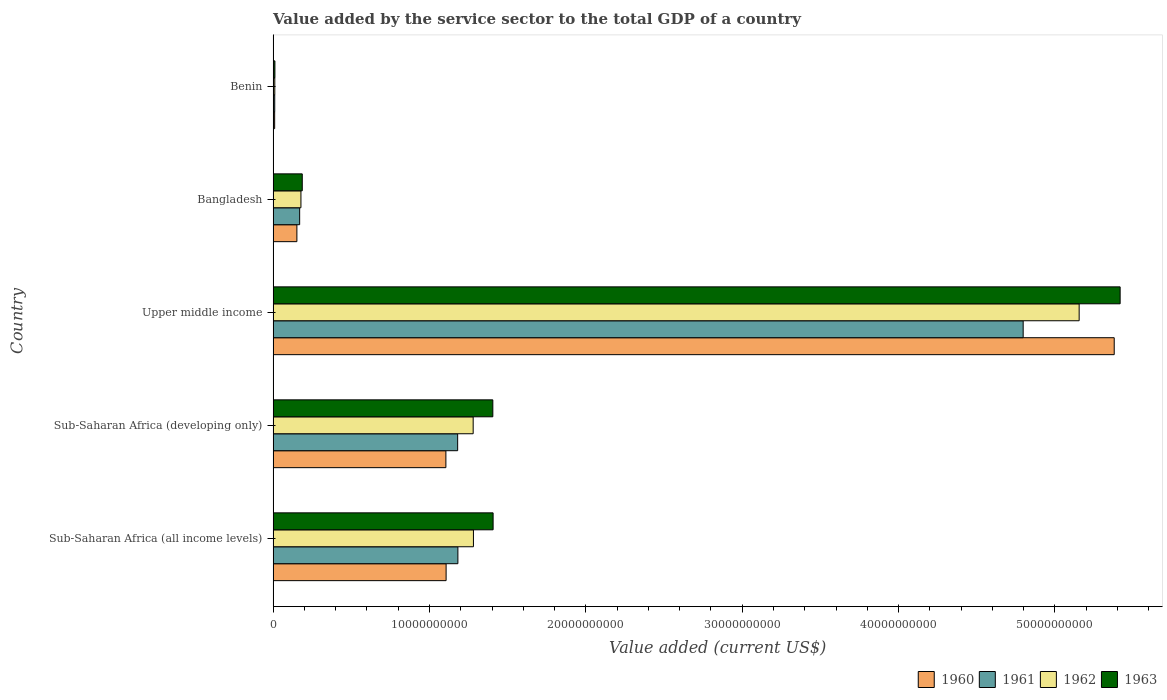How many different coloured bars are there?
Give a very brief answer. 4. How many groups of bars are there?
Your answer should be compact. 5. Are the number of bars on each tick of the Y-axis equal?
Ensure brevity in your answer.  Yes. How many bars are there on the 3rd tick from the top?
Keep it short and to the point. 4. How many bars are there on the 3rd tick from the bottom?
Make the answer very short. 4. What is the label of the 3rd group of bars from the top?
Keep it short and to the point. Upper middle income. In how many cases, is the number of bars for a given country not equal to the number of legend labels?
Your answer should be very brief. 0. What is the value added by the service sector to the total GDP in 1963 in Upper middle income?
Ensure brevity in your answer.  5.42e+1. Across all countries, what is the maximum value added by the service sector to the total GDP in 1962?
Ensure brevity in your answer.  5.16e+1. Across all countries, what is the minimum value added by the service sector to the total GDP in 1963?
Offer a very short reply. 1.14e+08. In which country was the value added by the service sector to the total GDP in 1960 maximum?
Make the answer very short. Upper middle income. In which country was the value added by the service sector to the total GDP in 1960 minimum?
Make the answer very short. Benin. What is the total value added by the service sector to the total GDP in 1962 in the graph?
Provide a short and direct response. 7.90e+1. What is the difference between the value added by the service sector to the total GDP in 1960 in Bangladesh and that in Sub-Saharan Africa (developing only)?
Your answer should be compact. -9.53e+09. What is the difference between the value added by the service sector to the total GDP in 1961 in Benin and the value added by the service sector to the total GDP in 1960 in Upper middle income?
Your answer should be compact. -5.37e+1. What is the average value added by the service sector to the total GDP in 1962 per country?
Keep it short and to the point. 1.58e+1. What is the difference between the value added by the service sector to the total GDP in 1960 and value added by the service sector to the total GDP in 1961 in Sub-Saharan Africa (developing only)?
Keep it short and to the point. -7.52e+08. What is the ratio of the value added by the service sector to the total GDP in 1963 in Benin to that in Sub-Saharan Africa (developing only)?
Give a very brief answer. 0.01. What is the difference between the highest and the second highest value added by the service sector to the total GDP in 1960?
Offer a very short reply. 4.27e+1. What is the difference between the highest and the lowest value added by the service sector to the total GDP in 1961?
Offer a terse response. 4.79e+1. Is the sum of the value added by the service sector to the total GDP in 1963 in Bangladesh and Upper middle income greater than the maximum value added by the service sector to the total GDP in 1960 across all countries?
Your answer should be very brief. Yes. What does the 2nd bar from the top in Sub-Saharan Africa (developing only) represents?
Your answer should be very brief. 1962. What does the 1st bar from the bottom in Benin represents?
Provide a succinct answer. 1960. Are all the bars in the graph horizontal?
Provide a short and direct response. Yes. What is the difference between two consecutive major ticks on the X-axis?
Your answer should be very brief. 1.00e+1. Are the values on the major ticks of X-axis written in scientific E-notation?
Your answer should be compact. No. Does the graph contain any zero values?
Your answer should be very brief. No. Does the graph contain grids?
Make the answer very short. No. What is the title of the graph?
Your answer should be compact. Value added by the service sector to the total GDP of a country. Does "1967" appear as one of the legend labels in the graph?
Keep it short and to the point. No. What is the label or title of the X-axis?
Give a very brief answer. Value added (current US$). What is the Value added (current US$) in 1960 in Sub-Saharan Africa (all income levels)?
Offer a very short reply. 1.11e+1. What is the Value added (current US$) in 1961 in Sub-Saharan Africa (all income levels)?
Offer a very short reply. 1.18e+1. What is the Value added (current US$) of 1962 in Sub-Saharan Africa (all income levels)?
Keep it short and to the point. 1.28e+1. What is the Value added (current US$) in 1963 in Sub-Saharan Africa (all income levels)?
Offer a very short reply. 1.41e+1. What is the Value added (current US$) in 1960 in Sub-Saharan Africa (developing only)?
Your response must be concise. 1.10e+1. What is the Value added (current US$) of 1961 in Sub-Saharan Africa (developing only)?
Provide a succinct answer. 1.18e+1. What is the Value added (current US$) of 1962 in Sub-Saharan Africa (developing only)?
Give a very brief answer. 1.28e+1. What is the Value added (current US$) in 1963 in Sub-Saharan Africa (developing only)?
Your answer should be compact. 1.41e+1. What is the Value added (current US$) of 1960 in Upper middle income?
Provide a succinct answer. 5.38e+1. What is the Value added (current US$) of 1961 in Upper middle income?
Offer a terse response. 4.80e+1. What is the Value added (current US$) in 1962 in Upper middle income?
Make the answer very short. 5.16e+1. What is the Value added (current US$) in 1963 in Upper middle income?
Keep it short and to the point. 5.42e+1. What is the Value added (current US$) in 1960 in Bangladesh?
Your answer should be very brief. 1.52e+09. What is the Value added (current US$) in 1961 in Bangladesh?
Make the answer very short. 1.70e+09. What is the Value added (current US$) of 1962 in Bangladesh?
Provide a succinct answer. 1.78e+09. What is the Value added (current US$) of 1963 in Bangladesh?
Your answer should be very brief. 1.86e+09. What is the Value added (current US$) in 1960 in Benin?
Provide a succinct answer. 9.87e+07. What is the Value added (current US$) in 1961 in Benin?
Keep it short and to the point. 1.04e+08. What is the Value added (current US$) in 1962 in Benin?
Give a very brief answer. 1.08e+08. What is the Value added (current US$) of 1963 in Benin?
Keep it short and to the point. 1.14e+08. Across all countries, what is the maximum Value added (current US$) in 1960?
Keep it short and to the point. 5.38e+1. Across all countries, what is the maximum Value added (current US$) of 1961?
Your answer should be compact. 4.80e+1. Across all countries, what is the maximum Value added (current US$) in 1962?
Offer a terse response. 5.16e+1. Across all countries, what is the maximum Value added (current US$) in 1963?
Provide a succinct answer. 5.42e+1. Across all countries, what is the minimum Value added (current US$) in 1960?
Offer a terse response. 9.87e+07. Across all countries, what is the minimum Value added (current US$) of 1961?
Your response must be concise. 1.04e+08. Across all countries, what is the minimum Value added (current US$) in 1962?
Your answer should be very brief. 1.08e+08. Across all countries, what is the minimum Value added (current US$) in 1963?
Provide a succinct answer. 1.14e+08. What is the total Value added (current US$) of 1960 in the graph?
Make the answer very short. 7.75e+1. What is the total Value added (current US$) in 1961 in the graph?
Offer a terse response. 7.34e+1. What is the total Value added (current US$) of 1962 in the graph?
Your answer should be compact. 7.90e+1. What is the total Value added (current US$) of 1963 in the graph?
Make the answer very short. 8.43e+1. What is the difference between the Value added (current US$) in 1960 in Sub-Saharan Africa (all income levels) and that in Sub-Saharan Africa (developing only)?
Offer a terse response. 1.42e+07. What is the difference between the Value added (current US$) of 1961 in Sub-Saharan Africa (all income levels) and that in Sub-Saharan Africa (developing only)?
Offer a very short reply. 1.52e+07. What is the difference between the Value added (current US$) in 1962 in Sub-Saharan Africa (all income levels) and that in Sub-Saharan Africa (developing only)?
Make the answer very short. 1.65e+07. What is the difference between the Value added (current US$) of 1963 in Sub-Saharan Africa (all income levels) and that in Sub-Saharan Africa (developing only)?
Your response must be concise. 1.81e+07. What is the difference between the Value added (current US$) in 1960 in Sub-Saharan Africa (all income levels) and that in Upper middle income?
Your response must be concise. -4.27e+1. What is the difference between the Value added (current US$) of 1961 in Sub-Saharan Africa (all income levels) and that in Upper middle income?
Offer a very short reply. -3.62e+1. What is the difference between the Value added (current US$) in 1962 in Sub-Saharan Africa (all income levels) and that in Upper middle income?
Provide a succinct answer. -3.87e+1. What is the difference between the Value added (current US$) of 1963 in Sub-Saharan Africa (all income levels) and that in Upper middle income?
Make the answer very short. -4.01e+1. What is the difference between the Value added (current US$) of 1960 in Sub-Saharan Africa (all income levels) and that in Bangladesh?
Ensure brevity in your answer.  9.54e+09. What is the difference between the Value added (current US$) of 1961 in Sub-Saharan Africa (all income levels) and that in Bangladesh?
Provide a succinct answer. 1.01e+1. What is the difference between the Value added (current US$) of 1962 in Sub-Saharan Africa (all income levels) and that in Bangladesh?
Your answer should be compact. 1.10e+1. What is the difference between the Value added (current US$) of 1963 in Sub-Saharan Africa (all income levels) and that in Bangladesh?
Offer a terse response. 1.22e+1. What is the difference between the Value added (current US$) in 1960 in Sub-Saharan Africa (all income levels) and that in Benin?
Offer a terse response. 1.10e+1. What is the difference between the Value added (current US$) in 1961 in Sub-Saharan Africa (all income levels) and that in Benin?
Ensure brevity in your answer.  1.17e+1. What is the difference between the Value added (current US$) in 1962 in Sub-Saharan Africa (all income levels) and that in Benin?
Give a very brief answer. 1.27e+1. What is the difference between the Value added (current US$) of 1963 in Sub-Saharan Africa (all income levels) and that in Benin?
Offer a terse response. 1.40e+1. What is the difference between the Value added (current US$) in 1960 in Sub-Saharan Africa (developing only) and that in Upper middle income?
Your response must be concise. -4.27e+1. What is the difference between the Value added (current US$) of 1961 in Sub-Saharan Africa (developing only) and that in Upper middle income?
Your response must be concise. -3.62e+1. What is the difference between the Value added (current US$) of 1962 in Sub-Saharan Africa (developing only) and that in Upper middle income?
Offer a terse response. -3.88e+1. What is the difference between the Value added (current US$) of 1963 in Sub-Saharan Africa (developing only) and that in Upper middle income?
Keep it short and to the point. -4.01e+1. What is the difference between the Value added (current US$) in 1960 in Sub-Saharan Africa (developing only) and that in Bangladesh?
Provide a succinct answer. 9.53e+09. What is the difference between the Value added (current US$) in 1961 in Sub-Saharan Africa (developing only) and that in Bangladesh?
Make the answer very short. 1.01e+1. What is the difference between the Value added (current US$) of 1962 in Sub-Saharan Africa (developing only) and that in Bangladesh?
Keep it short and to the point. 1.10e+1. What is the difference between the Value added (current US$) in 1963 in Sub-Saharan Africa (developing only) and that in Bangladesh?
Your answer should be compact. 1.22e+1. What is the difference between the Value added (current US$) of 1960 in Sub-Saharan Africa (developing only) and that in Benin?
Your answer should be very brief. 1.10e+1. What is the difference between the Value added (current US$) of 1961 in Sub-Saharan Africa (developing only) and that in Benin?
Your answer should be very brief. 1.17e+1. What is the difference between the Value added (current US$) of 1962 in Sub-Saharan Africa (developing only) and that in Benin?
Give a very brief answer. 1.27e+1. What is the difference between the Value added (current US$) in 1963 in Sub-Saharan Africa (developing only) and that in Benin?
Provide a succinct answer. 1.39e+1. What is the difference between the Value added (current US$) of 1960 in Upper middle income and that in Bangladesh?
Your answer should be very brief. 5.23e+1. What is the difference between the Value added (current US$) in 1961 in Upper middle income and that in Bangladesh?
Provide a short and direct response. 4.63e+1. What is the difference between the Value added (current US$) in 1962 in Upper middle income and that in Bangladesh?
Give a very brief answer. 4.98e+1. What is the difference between the Value added (current US$) in 1963 in Upper middle income and that in Bangladesh?
Provide a short and direct response. 5.23e+1. What is the difference between the Value added (current US$) in 1960 in Upper middle income and that in Benin?
Offer a very short reply. 5.37e+1. What is the difference between the Value added (current US$) in 1961 in Upper middle income and that in Benin?
Make the answer very short. 4.79e+1. What is the difference between the Value added (current US$) of 1962 in Upper middle income and that in Benin?
Offer a very short reply. 5.14e+1. What is the difference between the Value added (current US$) in 1963 in Upper middle income and that in Benin?
Keep it short and to the point. 5.41e+1. What is the difference between the Value added (current US$) of 1960 in Bangladesh and that in Benin?
Offer a terse response. 1.42e+09. What is the difference between the Value added (current US$) in 1961 in Bangladesh and that in Benin?
Make the answer very short. 1.59e+09. What is the difference between the Value added (current US$) of 1962 in Bangladesh and that in Benin?
Your answer should be very brief. 1.67e+09. What is the difference between the Value added (current US$) in 1963 in Bangladesh and that in Benin?
Make the answer very short. 1.75e+09. What is the difference between the Value added (current US$) in 1960 in Sub-Saharan Africa (all income levels) and the Value added (current US$) in 1961 in Sub-Saharan Africa (developing only)?
Provide a succinct answer. -7.38e+08. What is the difference between the Value added (current US$) of 1960 in Sub-Saharan Africa (all income levels) and the Value added (current US$) of 1962 in Sub-Saharan Africa (developing only)?
Offer a terse response. -1.73e+09. What is the difference between the Value added (current US$) in 1960 in Sub-Saharan Africa (all income levels) and the Value added (current US$) in 1963 in Sub-Saharan Africa (developing only)?
Make the answer very short. -2.99e+09. What is the difference between the Value added (current US$) of 1961 in Sub-Saharan Africa (all income levels) and the Value added (current US$) of 1962 in Sub-Saharan Africa (developing only)?
Offer a very short reply. -9.78e+08. What is the difference between the Value added (current US$) of 1961 in Sub-Saharan Africa (all income levels) and the Value added (current US$) of 1963 in Sub-Saharan Africa (developing only)?
Give a very brief answer. -2.23e+09. What is the difference between the Value added (current US$) of 1962 in Sub-Saharan Africa (all income levels) and the Value added (current US$) of 1963 in Sub-Saharan Africa (developing only)?
Provide a succinct answer. -1.24e+09. What is the difference between the Value added (current US$) in 1960 in Sub-Saharan Africa (all income levels) and the Value added (current US$) in 1961 in Upper middle income?
Offer a terse response. -3.69e+1. What is the difference between the Value added (current US$) of 1960 in Sub-Saharan Africa (all income levels) and the Value added (current US$) of 1962 in Upper middle income?
Provide a short and direct response. -4.05e+1. What is the difference between the Value added (current US$) in 1960 in Sub-Saharan Africa (all income levels) and the Value added (current US$) in 1963 in Upper middle income?
Offer a terse response. -4.31e+1. What is the difference between the Value added (current US$) of 1961 in Sub-Saharan Africa (all income levels) and the Value added (current US$) of 1962 in Upper middle income?
Give a very brief answer. -3.97e+1. What is the difference between the Value added (current US$) in 1961 in Sub-Saharan Africa (all income levels) and the Value added (current US$) in 1963 in Upper middle income?
Give a very brief answer. -4.24e+1. What is the difference between the Value added (current US$) of 1962 in Sub-Saharan Africa (all income levels) and the Value added (current US$) of 1963 in Upper middle income?
Offer a very short reply. -4.14e+1. What is the difference between the Value added (current US$) in 1960 in Sub-Saharan Africa (all income levels) and the Value added (current US$) in 1961 in Bangladesh?
Ensure brevity in your answer.  9.37e+09. What is the difference between the Value added (current US$) of 1960 in Sub-Saharan Africa (all income levels) and the Value added (current US$) of 1962 in Bangladesh?
Give a very brief answer. 9.28e+09. What is the difference between the Value added (current US$) of 1960 in Sub-Saharan Africa (all income levels) and the Value added (current US$) of 1963 in Bangladesh?
Offer a very short reply. 9.20e+09. What is the difference between the Value added (current US$) of 1961 in Sub-Saharan Africa (all income levels) and the Value added (current US$) of 1962 in Bangladesh?
Your response must be concise. 1.00e+1. What is the difference between the Value added (current US$) in 1961 in Sub-Saharan Africa (all income levels) and the Value added (current US$) in 1963 in Bangladesh?
Ensure brevity in your answer.  9.95e+09. What is the difference between the Value added (current US$) in 1962 in Sub-Saharan Africa (all income levels) and the Value added (current US$) in 1963 in Bangladesh?
Make the answer very short. 1.09e+1. What is the difference between the Value added (current US$) in 1960 in Sub-Saharan Africa (all income levels) and the Value added (current US$) in 1961 in Benin?
Make the answer very short. 1.10e+1. What is the difference between the Value added (current US$) of 1960 in Sub-Saharan Africa (all income levels) and the Value added (current US$) of 1962 in Benin?
Provide a short and direct response. 1.10e+1. What is the difference between the Value added (current US$) of 1960 in Sub-Saharan Africa (all income levels) and the Value added (current US$) of 1963 in Benin?
Keep it short and to the point. 1.10e+1. What is the difference between the Value added (current US$) of 1961 in Sub-Saharan Africa (all income levels) and the Value added (current US$) of 1962 in Benin?
Your response must be concise. 1.17e+1. What is the difference between the Value added (current US$) in 1961 in Sub-Saharan Africa (all income levels) and the Value added (current US$) in 1963 in Benin?
Ensure brevity in your answer.  1.17e+1. What is the difference between the Value added (current US$) of 1962 in Sub-Saharan Africa (all income levels) and the Value added (current US$) of 1963 in Benin?
Offer a terse response. 1.27e+1. What is the difference between the Value added (current US$) in 1960 in Sub-Saharan Africa (developing only) and the Value added (current US$) in 1961 in Upper middle income?
Your response must be concise. -3.69e+1. What is the difference between the Value added (current US$) in 1960 in Sub-Saharan Africa (developing only) and the Value added (current US$) in 1962 in Upper middle income?
Offer a terse response. -4.05e+1. What is the difference between the Value added (current US$) of 1960 in Sub-Saharan Africa (developing only) and the Value added (current US$) of 1963 in Upper middle income?
Give a very brief answer. -4.31e+1. What is the difference between the Value added (current US$) in 1961 in Sub-Saharan Africa (developing only) and the Value added (current US$) in 1962 in Upper middle income?
Provide a short and direct response. -3.97e+1. What is the difference between the Value added (current US$) of 1961 in Sub-Saharan Africa (developing only) and the Value added (current US$) of 1963 in Upper middle income?
Offer a terse response. -4.24e+1. What is the difference between the Value added (current US$) in 1962 in Sub-Saharan Africa (developing only) and the Value added (current US$) in 1963 in Upper middle income?
Your response must be concise. -4.14e+1. What is the difference between the Value added (current US$) in 1960 in Sub-Saharan Africa (developing only) and the Value added (current US$) in 1961 in Bangladesh?
Ensure brevity in your answer.  9.35e+09. What is the difference between the Value added (current US$) of 1960 in Sub-Saharan Africa (developing only) and the Value added (current US$) of 1962 in Bangladesh?
Offer a very short reply. 9.27e+09. What is the difference between the Value added (current US$) in 1960 in Sub-Saharan Africa (developing only) and the Value added (current US$) in 1963 in Bangladesh?
Provide a succinct answer. 9.19e+09. What is the difference between the Value added (current US$) in 1961 in Sub-Saharan Africa (developing only) and the Value added (current US$) in 1962 in Bangladesh?
Ensure brevity in your answer.  1.00e+1. What is the difference between the Value added (current US$) in 1961 in Sub-Saharan Africa (developing only) and the Value added (current US$) in 1963 in Bangladesh?
Your answer should be very brief. 9.94e+09. What is the difference between the Value added (current US$) of 1962 in Sub-Saharan Africa (developing only) and the Value added (current US$) of 1963 in Bangladesh?
Give a very brief answer. 1.09e+1. What is the difference between the Value added (current US$) of 1960 in Sub-Saharan Africa (developing only) and the Value added (current US$) of 1961 in Benin?
Offer a very short reply. 1.09e+1. What is the difference between the Value added (current US$) in 1960 in Sub-Saharan Africa (developing only) and the Value added (current US$) in 1962 in Benin?
Your response must be concise. 1.09e+1. What is the difference between the Value added (current US$) of 1960 in Sub-Saharan Africa (developing only) and the Value added (current US$) of 1963 in Benin?
Give a very brief answer. 1.09e+1. What is the difference between the Value added (current US$) of 1961 in Sub-Saharan Africa (developing only) and the Value added (current US$) of 1962 in Benin?
Your answer should be compact. 1.17e+1. What is the difference between the Value added (current US$) of 1961 in Sub-Saharan Africa (developing only) and the Value added (current US$) of 1963 in Benin?
Your answer should be compact. 1.17e+1. What is the difference between the Value added (current US$) of 1962 in Sub-Saharan Africa (developing only) and the Value added (current US$) of 1963 in Benin?
Make the answer very short. 1.27e+1. What is the difference between the Value added (current US$) of 1960 in Upper middle income and the Value added (current US$) of 1961 in Bangladesh?
Your response must be concise. 5.21e+1. What is the difference between the Value added (current US$) in 1960 in Upper middle income and the Value added (current US$) in 1962 in Bangladesh?
Offer a very short reply. 5.20e+1. What is the difference between the Value added (current US$) of 1960 in Upper middle income and the Value added (current US$) of 1963 in Bangladesh?
Your answer should be compact. 5.19e+1. What is the difference between the Value added (current US$) of 1961 in Upper middle income and the Value added (current US$) of 1962 in Bangladesh?
Offer a very short reply. 4.62e+1. What is the difference between the Value added (current US$) of 1961 in Upper middle income and the Value added (current US$) of 1963 in Bangladesh?
Ensure brevity in your answer.  4.61e+1. What is the difference between the Value added (current US$) in 1962 in Upper middle income and the Value added (current US$) in 1963 in Bangladesh?
Give a very brief answer. 4.97e+1. What is the difference between the Value added (current US$) of 1960 in Upper middle income and the Value added (current US$) of 1961 in Benin?
Your response must be concise. 5.37e+1. What is the difference between the Value added (current US$) in 1960 in Upper middle income and the Value added (current US$) in 1962 in Benin?
Give a very brief answer. 5.37e+1. What is the difference between the Value added (current US$) of 1960 in Upper middle income and the Value added (current US$) of 1963 in Benin?
Your response must be concise. 5.37e+1. What is the difference between the Value added (current US$) of 1961 in Upper middle income and the Value added (current US$) of 1962 in Benin?
Ensure brevity in your answer.  4.79e+1. What is the difference between the Value added (current US$) of 1961 in Upper middle income and the Value added (current US$) of 1963 in Benin?
Your answer should be compact. 4.79e+1. What is the difference between the Value added (current US$) of 1962 in Upper middle income and the Value added (current US$) of 1963 in Benin?
Your response must be concise. 5.14e+1. What is the difference between the Value added (current US$) of 1960 in Bangladesh and the Value added (current US$) of 1961 in Benin?
Provide a short and direct response. 1.42e+09. What is the difference between the Value added (current US$) of 1960 in Bangladesh and the Value added (current US$) of 1962 in Benin?
Your response must be concise. 1.41e+09. What is the difference between the Value added (current US$) in 1960 in Bangladesh and the Value added (current US$) in 1963 in Benin?
Offer a terse response. 1.41e+09. What is the difference between the Value added (current US$) of 1961 in Bangladesh and the Value added (current US$) of 1962 in Benin?
Provide a short and direct response. 1.59e+09. What is the difference between the Value added (current US$) of 1961 in Bangladesh and the Value added (current US$) of 1963 in Benin?
Offer a terse response. 1.58e+09. What is the difference between the Value added (current US$) in 1962 in Bangladesh and the Value added (current US$) in 1963 in Benin?
Offer a very short reply. 1.67e+09. What is the average Value added (current US$) in 1960 per country?
Keep it short and to the point. 1.55e+1. What is the average Value added (current US$) of 1961 per country?
Provide a short and direct response. 1.47e+1. What is the average Value added (current US$) of 1962 per country?
Provide a short and direct response. 1.58e+1. What is the average Value added (current US$) in 1963 per country?
Your response must be concise. 1.69e+1. What is the difference between the Value added (current US$) of 1960 and Value added (current US$) of 1961 in Sub-Saharan Africa (all income levels)?
Keep it short and to the point. -7.53e+08. What is the difference between the Value added (current US$) in 1960 and Value added (current US$) in 1962 in Sub-Saharan Africa (all income levels)?
Make the answer very short. -1.75e+09. What is the difference between the Value added (current US$) in 1960 and Value added (current US$) in 1963 in Sub-Saharan Africa (all income levels)?
Your answer should be very brief. -3.01e+09. What is the difference between the Value added (current US$) of 1961 and Value added (current US$) of 1962 in Sub-Saharan Africa (all income levels)?
Your response must be concise. -9.94e+08. What is the difference between the Value added (current US$) in 1961 and Value added (current US$) in 1963 in Sub-Saharan Africa (all income levels)?
Offer a terse response. -2.25e+09. What is the difference between the Value added (current US$) of 1962 and Value added (current US$) of 1963 in Sub-Saharan Africa (all income levels)?
Make the answer very short. -1.26e+09. What is the difference between the Value added (current US$) in 1960 and Value added (current US$) in 1961 in Sub-Saharan Africa (developing only)?
Ensure brevity in your answer.  -7.52e+08. What is the difference between the Value added (current US$) in 1960 and Value added (current US$) in 1962 in Sub-Saharan Africa (developing only)?
Offer a terse response. -1.75e+09. What is the difference between the Value added (current US$) of 1960 and Value added (current US$) of 1963 in Sub-Saharan Africa (developing only)?
Keep it short and to the point. -3.00e+09. What is the difference between the Value added (current US$) in 1961 and Value added (current US$) in 1962 in Sub-Saharan Africa (developing only)?
Your answer should be compact. -9.93e+08. What is the difference between the Value added (current US$) of 1961 and Value added (current US$) of 1963 in Sub-Saharan Africa (developing only)?
Provide a succinct answer. -2.25e+09. What is the difference between the Value added (current US$) of 1962 and Value added (current US$) of 1963 in Sub-Saharan Africa (developing only)?
Offer a terse response. -1.26e+09. What is the difference between the Value added (current US$) of 1960 and Value added (current US$) of 1961 in Upper middle income?
Offer a terse response. 5.82e+09. What is the difference between the Value added (current US$) in 1960 and Value added (current US$) in 1962 in Upper middle income?
Offer a terse response. 2.24e+09. What is the difference between the Value added (current US$) of 1960 and Value added (current US$) of 1963 in Upper middle income?
Make the answer very short. -3.78e+08. What is the difference between the Value added (current US$) of 1961 and Value added (current US$) of 1962 in Upper middle income?
Your answer should be very brief. -3.58e+09. What is the difference between the Value added (current US$) of 1961 and Value added (current US$) of 1963 in Upper middle income?
Provide a short and direct response. -6.20e+09. What is the difference between the Value added (current US$) in 1962 and Value added (current US$) in 1963 in Upper middle income?
Provide a succinct answer. -2.62e+09. What is the difference between the Value added (current US$) of 1960 and Value added (current US$) of 1961 in Bangladesh?
Your response must be concise. -1.77e+08. What is the difference between the Value added (current US$) of 1960 and Value added (current US$) of 1962 in Bangladesh?
Provide a succinct answer. -2.60e+08. What is the difference between the Value added (current US$) of 1960 and Value added (current US$) of 1963 in Bangladesh?
Your answer should be very brief. -3.45e+08. What is the difference between the Value added (current US$) in 1961 and Value added (current US$) in 1962 in Bangladesh?
Give a very brief answer. -8.27e+07. What is the difference between the Value added (current US$) in 1961 and Value added (current US$) in 1963 in Bangladesh?
Offer a very short reply. -1.68e+08. What is the difference between the Value added (current US$) of 1962 and Value added (current US$) of 1963 in Bangladesh?
Your answer should be very brief. -8.50e+07. What is the difference between the Value added (current US$) of 1960 and Value added (current US$) of 1961 in Benin?
Your answer should be compact. -5.02e+06. What is the difference between the Value added (current US$) in 1960 and Value added (current US$) in 1962 in Benin?
Ensure brevity in your answer.  -8.92e+06. What is the difference between the Value added (current US$) in 1960 and Value added (current US$) in 1963 in Benin?
Make the answer very short. -1.51e+07. What is the difference between the Value added (current US$) in 1961 and Value added (current US$) in 1962 in Benin?
Offer a terse response. -3.90e+06. What is the difference between the Value added (current US$) in 1961 and Value added (current US$) in 1963 in Benin?
Your answer should be very brief. -1.01e+07. What is the difference between the Value added (current US$) in 1962 and Value added (current US$) in 1963 in Benin?
Keep it short and to the point. -6.21e+06. What is the ratio of the Value added (current US$) in 1960 in Sub-Saharan Africa (all income levels) to that in Sub-Saharan Africa (developing only)?
Your response must be concise. 1. What is the ratio of the Value added (current US$) in 1960 in Sub-Saharan Africa (all income levels) to that in Upper middle income?
Provide a short and direct response. 0.21. What is the ratio of the Value added (current US$) of 1961 in Sub-Saharan Africa (all income levels) to that in Upper middle income?
Your answer should be compact. 0.25. What is the ratio of the Value added (current US$) of 1962 in Sub-Saharan Africa (all income levels) to that in Upper middle income?
Give a very brief answer. 0.25. What is the ratio of the Value added (current US$) in 1963 in Sub-Saharan Africa (all income levels) to that in Upper middle income?
Make the answer very short. 0.26. What is the ratio of the Value added (current US$) of 1960 in Sub-Saharan Africa (all income levels) to that in Bangladesh?
Make the answer very short. 7.28. What is the ratio of the Value added (current US$) in 1961 in Sub-Saharan Africa (all income levels) to that in Bangladesh?
Offer a very short reply. 6.96. What is the ratio of the Value added (current US$) of 1962 in Sub-Saharan Africa (all income levels) to that in Bangladesh?
Give a very brief answer. 7.2. What is the ratio of the Value added (current US$) in 1963 in Sub-Saharan Africa (all income levels) to that in Bangladesh?
Your answer should be compact. 7.55. What is the ratio of the Value added (current US$) in 1960 in Sub-Saharan Africa (all income levels) to that in Benin?
Ensure brevity in your answer.  112.15. What is the ratio of the Value added (current US$) in 1961 in Sub-Saharan Africa (all income levels) to that in Benin?
Your answer should be very brief. 113.98. What is the ratio of the Value added (current US$) of 1962 in Sub-Saharan Africa (all income levels) to that in Benin?
Your response must be concise. 119.09. What is the ratio of the Value added (current US$) in 1963 in Sub-Saharan Africa (all income levels) to that in Benin?
Offer a very short reply. 123.64. What is the ratio of the Value added (current US$) in 1960 in Sub-Saharan Africa (developing only) to that in Upper middle income?
Your answer should be compact. 0.21. What is the ratio of the Value added (current US$) of 1961 in Sub-Saharan Africa (developing only) to that in Upper middle income?
Your answer should be compact. 0.25. What is the ratio of the Value added (current US$) in 1962 in Sub-Saharan Africa (developing only) to that in Upper middle income?
Your response must be concise. 0.25. What is the ratio of the Value added (current US$) in 1963 in Sub-Saharan Africa (developing only) to that in Upper middle income?
Offer a very short reply. 0.26. What is the ratio of the Value added (current US$) of 1960 in Sub-Saharan Africa (developing only) to that in Bangladesh?
Your answer should be very brief. 7.27. What is the ratio of the Value added (current US$) in 1961 in Sub-Saharan Africa (developing only) to that in Bangladesh?
Offer a very short reply. 6.96. What is the ratio of the Value added (current US$) in 1962 in Sub-Saharan Africa (developing only) to that in Bangladesh?
Your response must be concise. 7.19. What is the ratio of the Value added (current US$) in 1963 in Sub-Saharan Africa (developing only) to that in Bangladesh?
Ensure brevity in your answer.  7.54. What is the ratio of the Value added (current US$) of 1960 in Sub-Saharan Africa (developing only) to that in Benin?
Offer a very short reply. 112. What is the ratio of the Value added (current US$) of 1961 in Sub-Saharan Africa (developing only) to that in Benin?
Provide a succinct answer. 113.83. What is the ratio of the Value added (current US$) of 1962 in Sub-Saharan Africa (developing only) to that in Benin?
Make the answer very short. 118.94. What is the ratio of the Value added (current US$) in 1963 in Sub-Saharan Africa (developing only) to that in Benin?
Your response must be concise. 123.48. What is the ratio of the Value added (current US$) in 1960 in Upper middle income to that in Bangladesh?
Your answer should be very brief. 35.4. What is the ratio of the Value added (current US$) of 1961 in Upper middle income to that in Bangladesh?
Give a very brief answer. 28.27. What is the ratio of the Value added (current US$) of 1962 in Upper middle income to that in Bangladesh?
Offer a very short reply. 28.97. What is the ratio of the Value added (current US$) in 1963 in Upper middle income to that in Bangladesh?
Your answer should be very brief. 29.06. What is the ratio of the Value added (current US$) in 1960 in Upper middle income to that in Benin?
Your answer should be very brief. 545.27. What is the ratio of the Value added (current US$) in 1961 in Upper middle income to that in Benin?
Give a very brief answer. 462.69. What is the ratio of the Value added (current US$) in 1962 in Upper middle income to that in Benin?
Offer a very short reply. 479.2. What is the ratio of the Value added (current US$) in 1963 in Upper middle income to that in Benin?
Provide a short and direct response. 476.07. What is the ratio of the Value added (current US$) in 1960 in Bangladesh to that in Benin?
Ensure brevity in your answer.  15.41. What is the ratio of the Value added (current US$) of 1961 in Bangladesh to that in Benin?
Make the answer very short. 16.36. What is the ratio of the Value added (current US$) in 1962 in Bangladesh to that in Benin?
Ensure brevity in your answer.  16.54. What is the ratio of the Value added (current US$) of 1963 in Bangladesh to that in Benin?
Offer a terse response. 16.38. What is the difference between the highest and the second highest Value added (current US$) of 1960?
Offer a terse response. 4.27e+1. What is the difference between the highest and the second highest Value added (current US$) of 1961?
Your response must be concise. 3.62e+1. What is the difference between the highest and the second highest Value added (current US$) in 1962?
Keep it short and to the point. 3.87e+1. What is the difference between the highest and the second highest Value added (current US$) of 1963?
Your answer should be compact. 4.01e+1. What is the difference between the highest and the lowest Value added (current US$) of 1960?
Offer a terse response. 5.37e+1. What is the difference between the highest and the lowest Value added (current US$) of 1961?
Make the answer very short. 4.79e+1. What is the difference between the highest and the lowest Value added (current US$) of 1962?
Keep it short and to the point. 5.14e+1. What is the difference between the highest and the lowest Value added (current US$) in 1963?
Your answer should be very brief. 5.41e+1. 